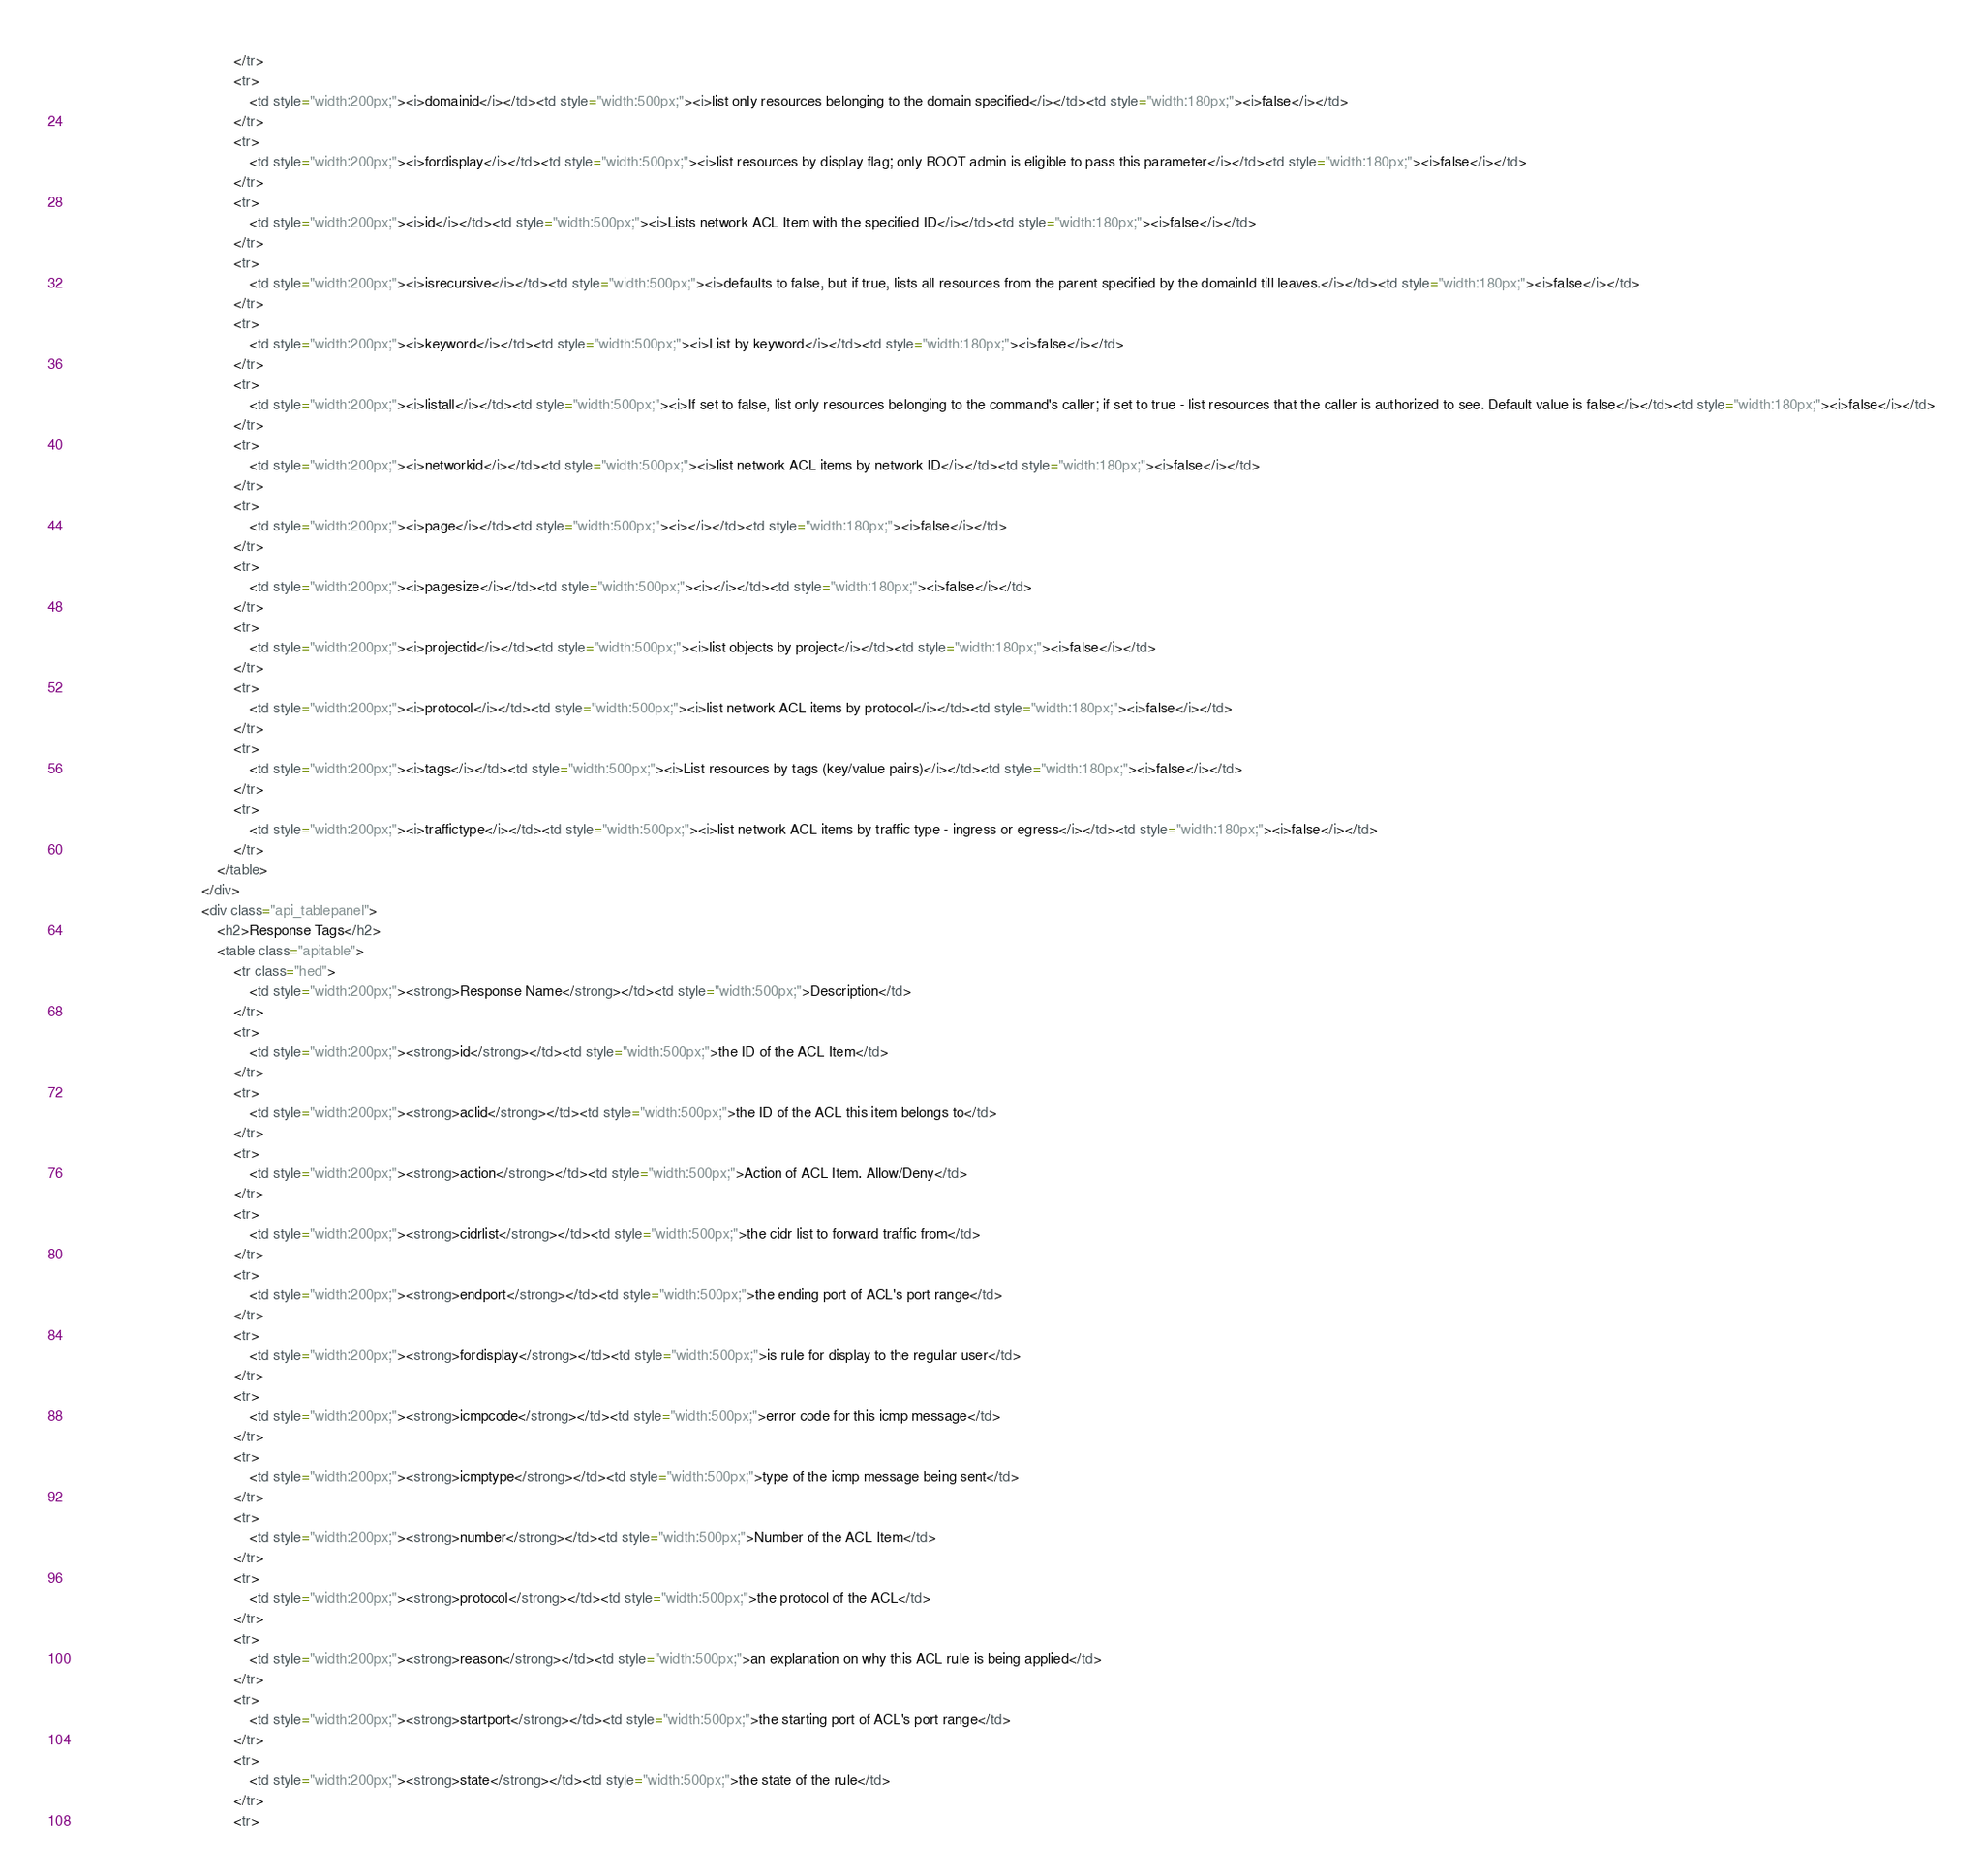<code> <loc_0><loc_0><loc_500><loc_500><_HTML_>                                        </tr>
                                        <tr>
                                            <td style="width:200px;"><i>domainid</i></td><td style="width:500px;"><i>list only resources belonging to the domain specified</i></td><td style="width:180px;"><i>false</i></td>
                                        </tr>
                                        <tr>
                                            <td style="width:200px;"><i>fordisplay</i></td><td style="width:500px;"><i>list resources by display flag; only ROOT admin is eligible to pass this parameter</i></td><td style="width:180px;"><i>false</i></td>
                                        </tr>
                                        <tr>
                                            <td style="width:200px;"><i>id</i></td><td style="width:500px;"><i>Lists network ACL Item with the specified ID</i></td><td style="width:180px;"><i>false</i></td>
                                        </tr>
                                        <tr>
                                            <td style="width:200px;"><i>isrecursive</i></td><td style="width:500px;"><i>defaults to false, but if true, lists all resources from the parent specified by the domainId till leaves.</i></td><td style="width:180px;"><i>false</i></td>
                                        </tr>
                                        <tr>
                                            <td style="width:200px;"><i>keyword</i></td><td style="width:500px;"><i>List by keyword</i></td><td style="width:180px;"><i>false</i></td>
                                        </tr>
                                        <tr>
                                            <td style="width:200px;"><i>listall</i></td><td style="width:500px;"><i>If set to false, list only resources belonging to the command's caller; if set to true - list resources that the caller is authorized to see. Default value is false</i></td><td style="width:180px;"><i>false</i></td>
                                        </tr>
                                        <tr>
                                            <td style="width:200px;"><i>networkid</i></td><td style="width:500px;"><i>list network ACL items by network ID</i></td><td style="width:180px;"><i>false</i></td>
                                        </tr>
                                        <tr>
                                            <td style="width:200px;"><i>page</i></td><td style="width:500px;"><i></i></td><td style="width:180px;"><i>false</i></td>
                                        </tr>
                                        <tr>
                                            <td style="width:200px;"><i>pagesize</i></td><td style="width:500px;"><i></i></td><td style="width:180px;"><i>false</i></td>
                                        </tr>
                                        <tr>
                                            <td style="width:200px;"><i>projectid</i></td><td style="width:500px;"><i>list objects by project</i></td><td style="width:180px;"><i>false</i></td>
                                        </tr>
                                        <tr>
                                            <td style="width:200px;"><i>protocol</i></td><td style="width:500px;"><i>list network ACL items by protocol</i></td><td style="width:180px;"><i>false</i></td>
                                        </tr>
                                        <tr>
                                            <td style="width:200px;"><i>tags</i></td><td style="width:500px;"><i>List resources by tags (key/value pairs)</i></td><td style="width:180px;"><i>false</i></td>
                                        </tr>
                                        <tr>
                                            <td style="width:200px;"><i>traffictype</i></td><td style="width:500px;"><i>list network ACL items by traffic type - ingress or egress</i></td><td style="width:180px;"><i>false</i></td>
                                        </tr>
                                    </table>
                                </div>
                                <div class="api_tablepanel">
                                    <h2>Response Tags</h2>
                                    <table class="apitable">
                                        <tr class="hed">
                                            <td style="width:200px;"><strong>Response Name</strong></td><td style="width:500px;">Description</td>
                                        </tr>
                                        <tr>
                                            <td style="width:200px;"><strong>id</strong></td><td style="width:500px;">the ID of the ACL Item</td>
                                        </tr>
                                        <tr>
                                            <td style="width:200px;"><strong>aclid</strong></td><td style="width:500px;">the ID of the ACL this item belongs to</td>
                                        </tr>
                                        <tr>
                                            <td style="width:200px;"><strong>action</strong></td><td style="width:500px;">Action of ACL Item. Allow/Deny</td>
                                        </tr>
                                        <tr>
                                            <td style="width:200px;"><strong>cidrlist</strong></td><td style="width:500px;">the cidr list to forward traffic from</td>
                                        </tr>
                                        <tr>
                                            <td style="width:200px;"><strong>endport</strong></td><td style="width:500px;">the ending port of ACL's port range</td>
                                        </tr>
                                        <tr>
                                            <td style="width:200px;"><strong>fordisplay</strong></td><td style="width:500px;">is rule for display to the regular user</td>
                                        </tr>
                                        <tr>
                                            <td style="width:200px;"><strong>icmpcode</strong></td><td style="width:500px;">error code for this icmp message</td>
                                        </tr>
                                        <tr>
                                            <td style="width:200px;"><strong>icmptype</strong></td><td style="width:500px;">type of the icmp message being sent</td>
                                        </tr>
                                        <tr>
                                            <td style="width:200px;"><strong>number</strong></td><td style="width:500px;">Number of the ACL Item</td>
                                        </tr>
                                        <tr>
                                            <td style="width:200px;"><strong>protocol</strong></td><td style="width:500px;">the protocol of the ACL</td>
                                        </tr>
                                        <tr>
                                            <td style="width:200px;"><strong>reason</strong></td><td style="width:500px;">an explanation on why this ACL rule is being applied</td>
                                        </tr>
                                        <tr>
                                            <td style="width:200px;"><strong>startport</strong></td><td style="width:500px;">the starting port of ACL's port range</td>
                                        </tr>
                                        <tr>
                                            <td style="width:200px;"><strong>state</strong></td><td style="width:500px;">the state of the rule</td>
                                        </tr>
                                        <tr></code> 